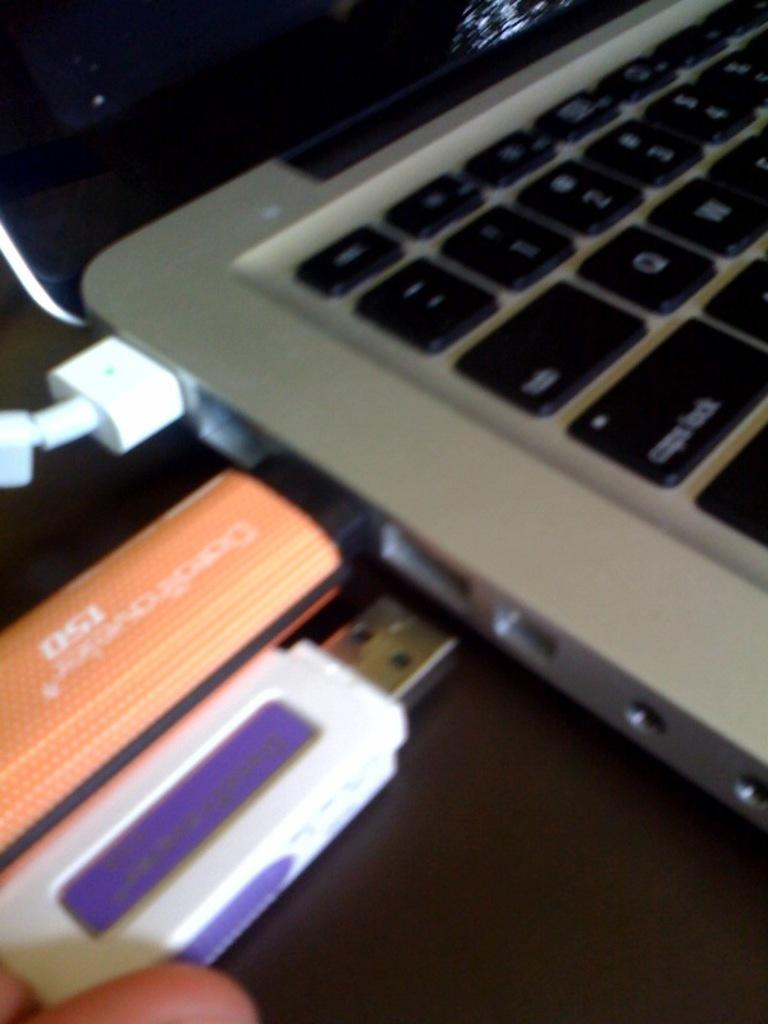How many pen drives are visible in the image? There are two pen drives in the image. What is connected to the laptop in the image? A cable is attached to a laptop in the image. What is the person's finger holding in the image? The person's finger is holding a pen drive in the image. What type of device is visible in the image that can be used for computing? There is a laptop in the image. How many pizzas are being served to the person in the image? There are no pizzas present in the image. What type of slave is depicted in the image? There is no depiction of a slave in the image. 